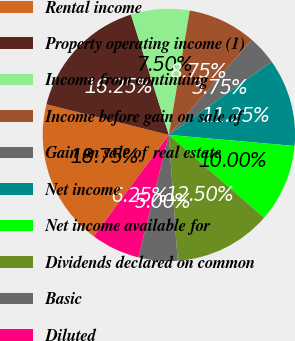Convert chart to OTSL. <chart><loc_0><loc_0><loc_500><loc_500><pie_chart><fcel>Rental income<fcel>Property operating income (1)<fcel>Income from continuing<fcel>Income before gain on sale of<fcel>Gain on sale of real estate<fcel>Net income<fcel>Net income available for<fcel>Dividends declared on common<fcel>Basic<fcel>Diluted<nl><fcel>18.75%<fcel>16.25%<fcel>7.5%<fcel>8.75%<fcel>3.75%<fcel>11.25%<fcel>10.0%<fcel>12.5%<fcel>5.0%<fcel>6.25%<nl></chart> 